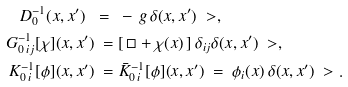<formula> <loc_0><loc_0><loc_500><loc_500>D _ { 0 } ^ { - 1 } ( x , x ^ { \prime } ) \ = \ & - \, g \, \delta ( x , x ^ { \prime } ) \ > , \\ G _ { 0 \, i j } ^ { - 1 } [ \chi ] ( x , x ^ { \prime } ) \ = \ & [ \, \Box + \chi ( x ) \, ] \, \delta _ { i j } \delta ( x , x ^ { \prime } ) \ > , \\ K _ { 0 \, i } ^ { - 1 } [ \phi ] ( x , x ^ { \prime } ) \ = \ & \bar { K } _ { 0 \, i } ^ { - 1 } [ \phi ] ( x , x ^ { \prime } ) \ = \ \phi _ { i } ( x ) \, \delta ( x , x ^ { \prime } ) \ > .</formula> 